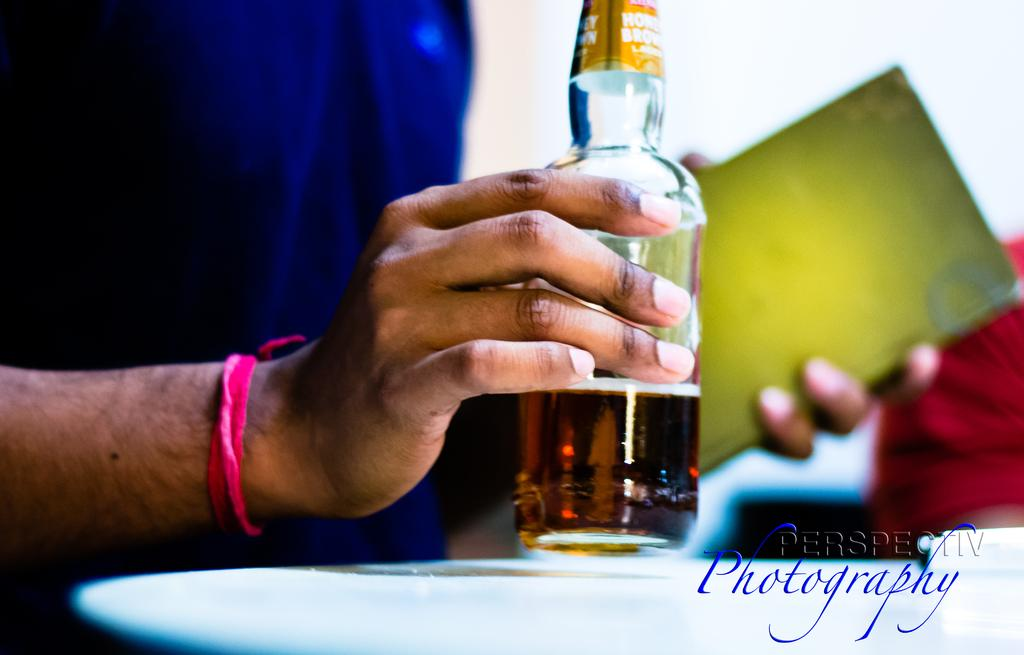Provide a one-sentence caption for the provided image. Someone holds a bottle in one hand and a green book in the other, and the photographers logo appears on the image. 